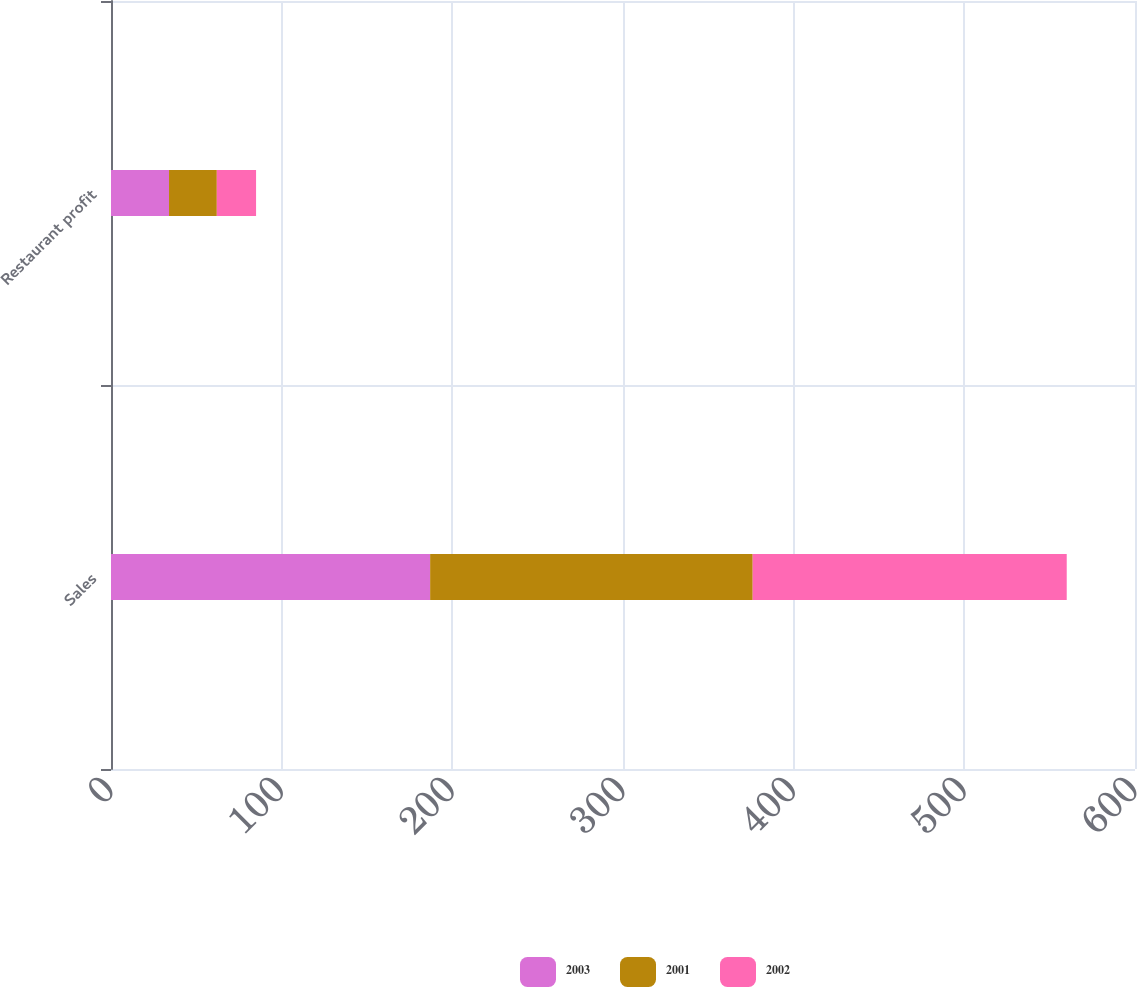<chart> <loc_0><loc_0><loc_500><loc_500><stacked_bar_chart><ecel><fcel>Sales<fcel>Restaurant profit<nl><fcel>2003<fcel>187<fcel>34<nl><fcel>2001<fcel>189<fcel>28<nl><fcel>2002<fcel>184<fcel>23<nl></chart> 